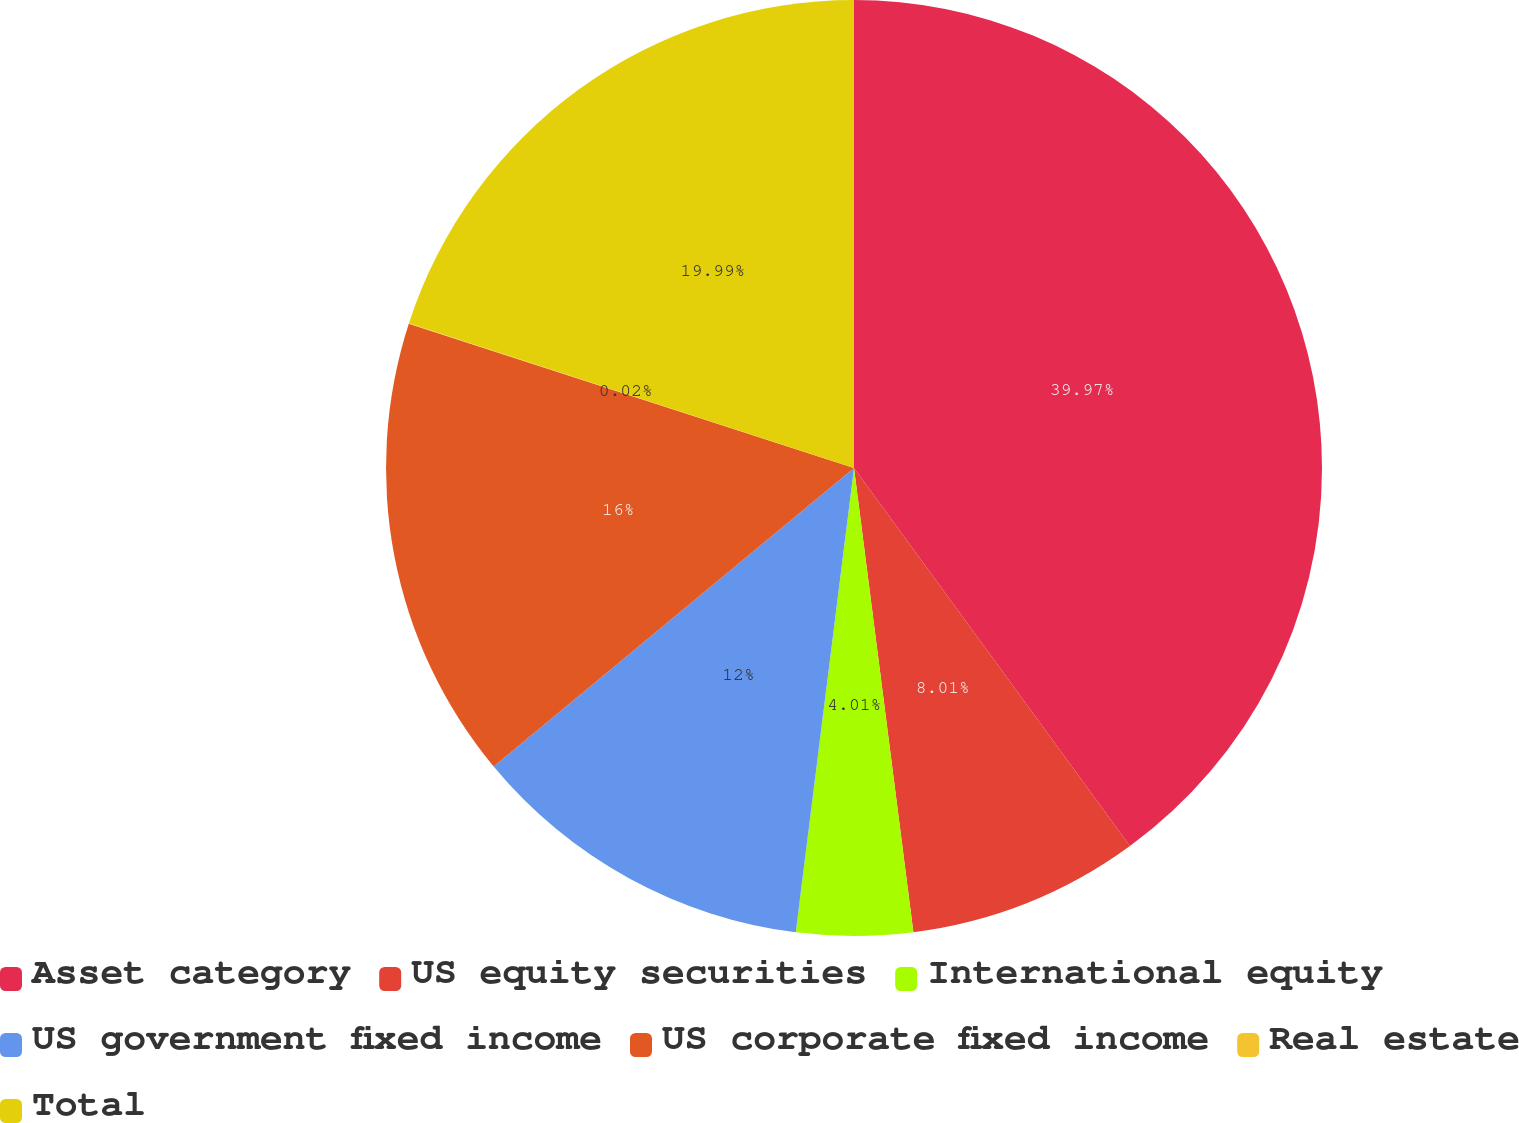Convert chart to OTSL. <chart><loc_0><loc_0><loc_500><loc_500><pie_chart><fcel>Asset category<fcel>US equity securities<fcel>International equity<fcel>US government fixed income<fcel>US corporate fixed income<fcel>Real estate<fcel>Total<nl><fcel>39.96%<fcel>8.01%<fcel>4.01%<fcel>12.0%<fcel>16.0%<fcel>0.02%<fcel>19.99%<nl></chart> 